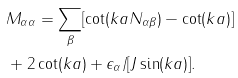Convert formula to latex. <formula><loc_0><loc_0><loc_500><loc_500>& M _ { \alpha \alpha } = \sum _ { \beta } [ \cot ( k a N _ { \alpha \beta } ) - \cot ( k a ) ] \\ & + 2 \cot ( k a ) + \epsilon _ { \alpha } / [ J \sin ( k a ) ] .</formula> 